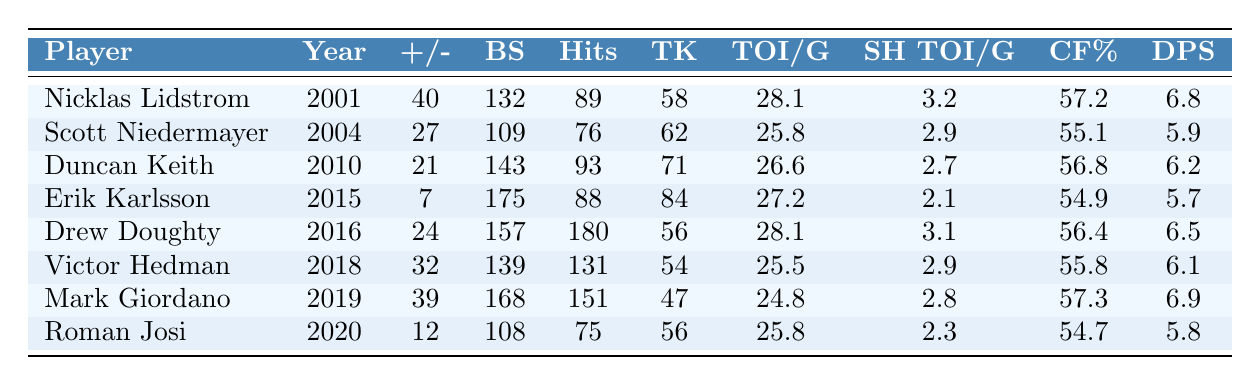What player had the highest Plus/Minus value? By examining the Plus/Minus column, the highest value is 40, which belongs to Nicklas Lidstrom in 2001.
Answer: Nicklas Lidstrom In what year did Duncan Keith win the Norris Trophy? Looking at the Year column associated with Duncan Keith, he won the Norris Trophy in 2010.
Answer: 2010 How many Blocked Shots did Erik Karlsson have in his winning year? Checking the Blocked Shots column for Erik Karlsson, it shows 175 for the year 2015.
Answer: 175 Which player had the most Hits in a single season? By reviewing the Hits column, Drew Doughty has the highest number at 180 during the year 2016.
Answer: Drew Doughty What is the average Time on Ice per Game for all the players listed? Adding the Time on Ice/Game values (28.1 + 25.8 + 26.6 + 27.2 + 28.1 + 25.5 + 24.8 + 25.8) gives 207.1, and dividing by the number of players (8) results in an average of 25.89.
Answer: 25.89 Did any player have a higher Corsi For % than Mark Giordano in 2019? Mark Giordano had a Corsi For % of 57.3; comparing this to other players, both Nicklas Lidstrom and Duncan Keith had higher values at 57.2 and 56.8, respectively, so no player exceeded 57.3.
Answer: No Which player recorded the lowest Defensive Point Shares? Reviewing the Defensive Point Shares column, Roman Josi has the lowest value at 5.8 for the year 2020.
Answer: Roman Josi How many more Blocked Shots did Drew Doughty have compared to Scott Niedermayer? Drew Doughty recorded 157 Blocked Shots, while Scott Niedermayer had 109. The difference is 157 - 109 = 48.
Answer: 48 What was the total number of Takeaways for all players combined? Summing all Takeaways (58 + 62 + 71 + 84 + 56 + 54 + 47 + 56) results in 428 Takeaways for all the players together.
Answer: 428 Was Victor Hedman's Shorthanded Time on Ice/Game higher than Roman Josi's? Victor Hedman had a Shorthanded Time on Ice/Game of 2.9, while Roman Josi had only 2.3, so Hedman's was higher.
Answer: Yes 